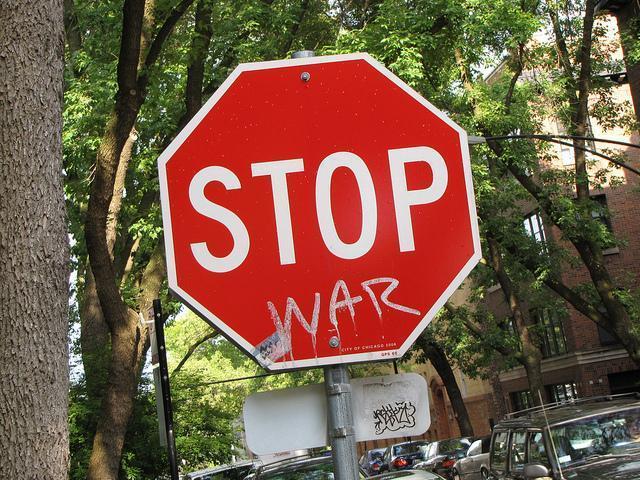How many cars are there?
Give a very brief answer. 2. How many orange buttons on the toilet?
Give a very brief answer. 0. 